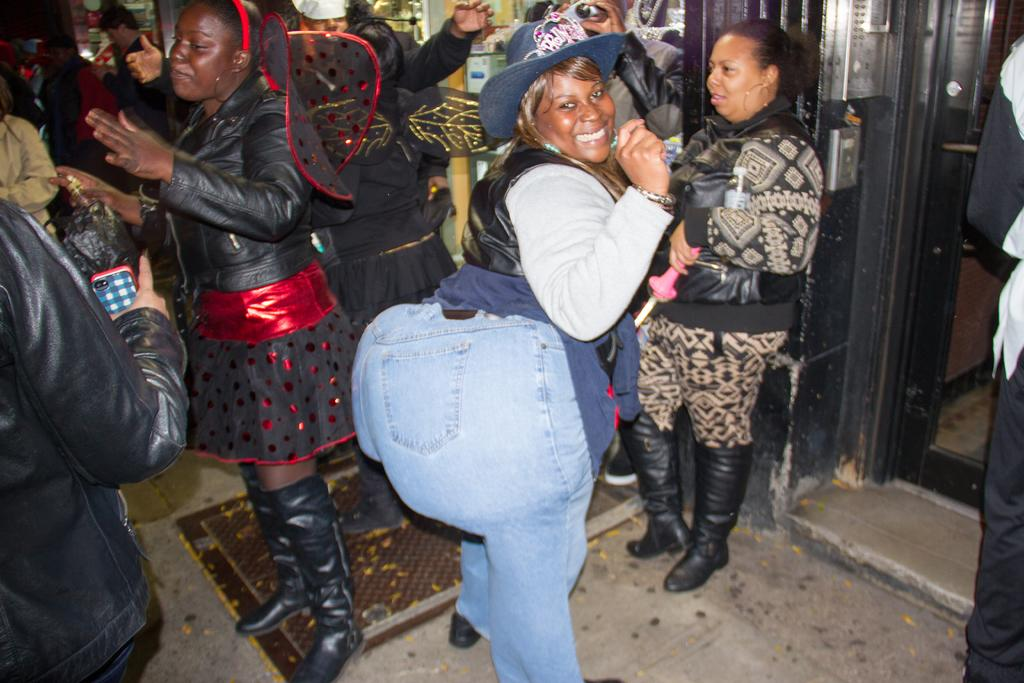Who or what is present in the image? There are people in the image. What can be seen in the background or as a part of the setting? There is a door in the image. Are there any items or objects arranged or displayed in the image? Yes, there are objects on shelves in the image. How many toys are being used by the people in the image? There is no mention of toys in the image, so it is impossible to determine how many are being used. 